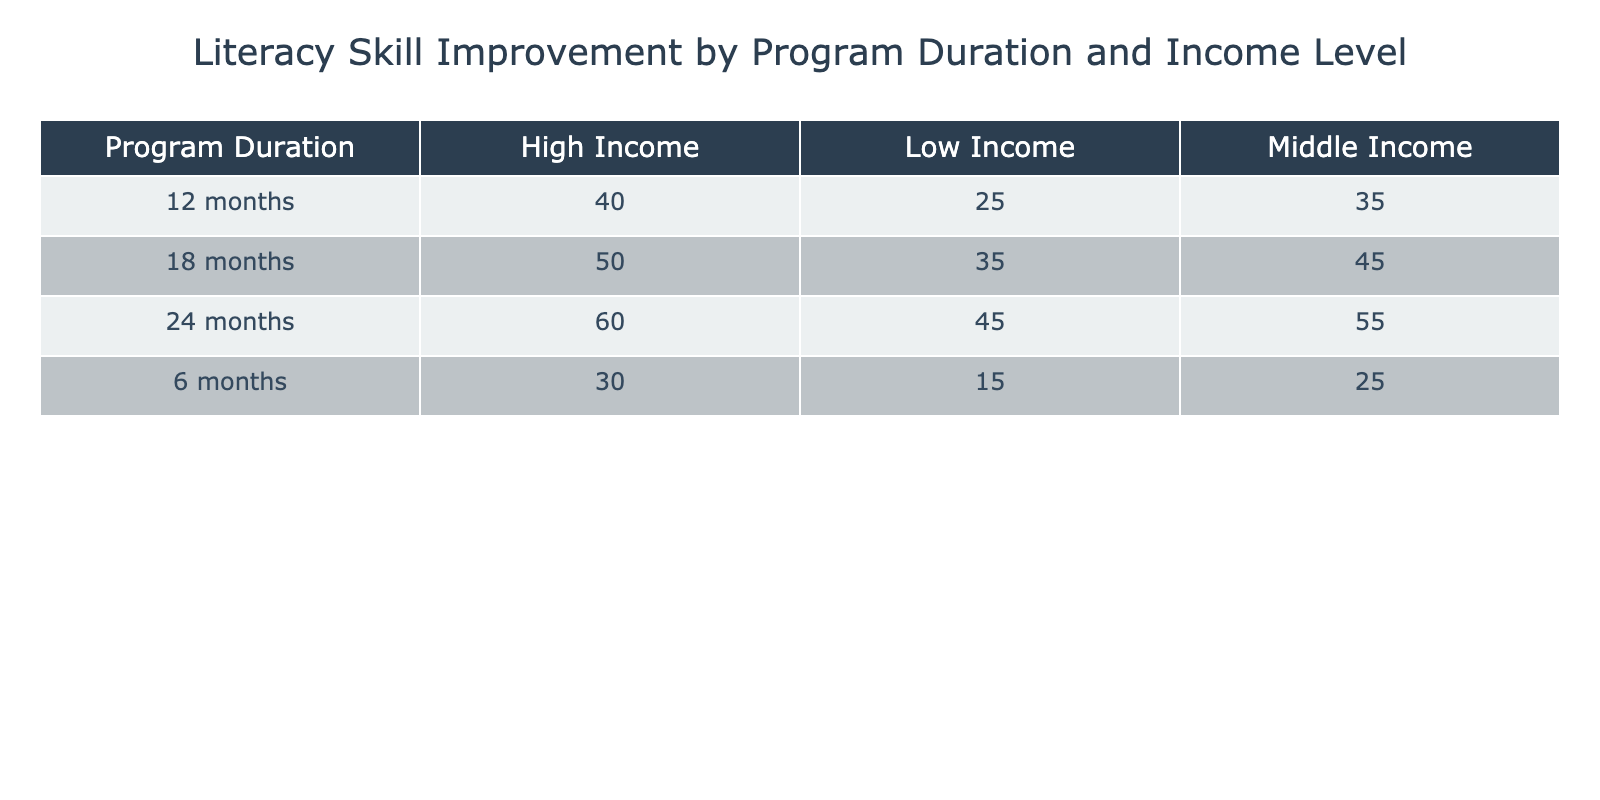What is the literacy skill improvement level for participants with high income in the 12-month program? From the table, locate the row for the 12-month program and the column for high income. The value where these intersect is 40.
Answer: 40 What is the literacy skill improvement level for low-income participants with a program duration of 18 months? The relevant row is for the 18-month program and the column for low income. The intersecting value in the table is 35.
Answer: 35 Is the literacy skill improvement for middle-income participants in the 24-month program greater than that of low-income participants in the same program? First, identify the values for middle income (55) and low income (45) under the 24-month program. Since 55 is greater than 45, the statement is true.
Answer: Yes What is the average literacy skill improvement level for low-income participants across all program durations? Sum the values for low income across all durations: (15 + 25 + 35 + 45) = 120. Then divide by the number of durations (4), which gives 120 / 4 = 30.
Answer: 30 What is the difference in literacy skill improvement between participants in the 6-month program and those in the 24-month program for middle-income participants? The literacy skill improvement for middle-income participants in the 6-month program is 25, and in the 24-month program, it is 55. The difference is 55 - 25 = 30.
Answer: 30 Are there any program durations where the literacy skill improvement for high-income participants is less than for low-income participants? Looking at each program duration, we find that high income values (30, 40, 50, 60) are all greater than low income values (15, 25, 35, 45). Hence, the answer is no.
Answer: No What program duration shows the greatest literacy skill improvement for middle-income participants? Reviewing the values for middle income, we have 25 (6 months), 35 (12 months), 45 (18 months), and 55 (24 months). The greatest value is 55 for the 24-month program.
Answer: 24 months What is the literacy skill improvement level for low-income participants in the 6-month program compared to the same group in the 18-month program? The value for low-income participants in the 6-month program is 15, while in the 18-month program, it is 35. Comparing these values, 35 is greater than 15.
Answer: Greater in 18-month program What is the total literacy skill improvement level for all high-income participants across all program durations? Sum the values for high income across all durations: (30 + 40 + 50 + 60) = 180.
Answer: 180 